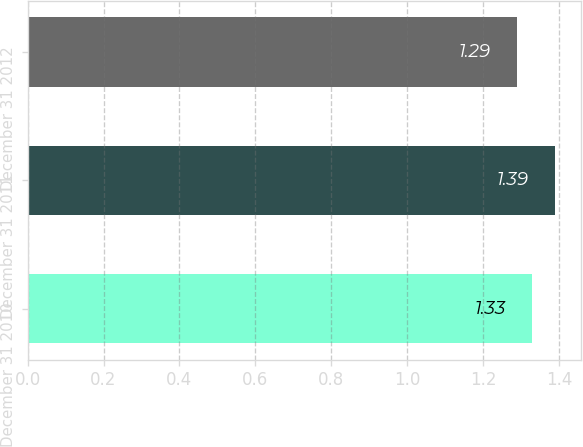Convert chart. <chart><loc_0><loc_0><loc_500><loc_500><bar_chart><fcel>December 31 2010<fcel>December 31 2011<fcel>December 31 2012<nl><fcel>1.33<fcel>1.39<fcel>1.29<nl></chart> 